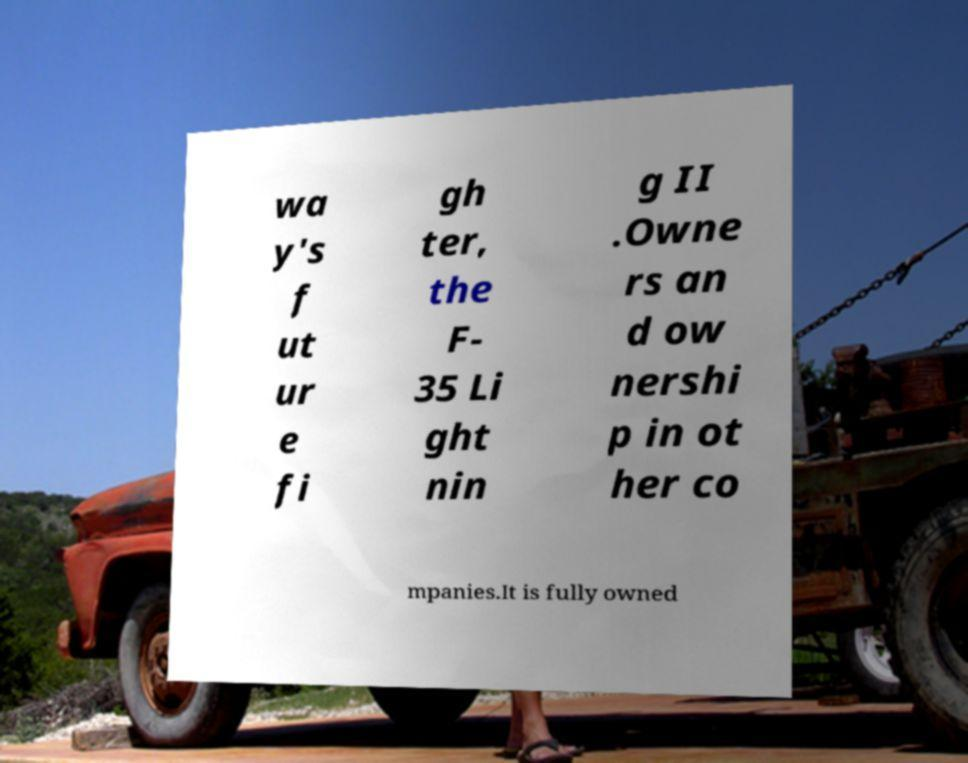Could you extract and type out the text from this image? wa y's f ut ur e fi gh ter, the F- 35 Li ght nin g II .Owne rs an d ow nershi p in ot her co mpanies.It is fully owned 